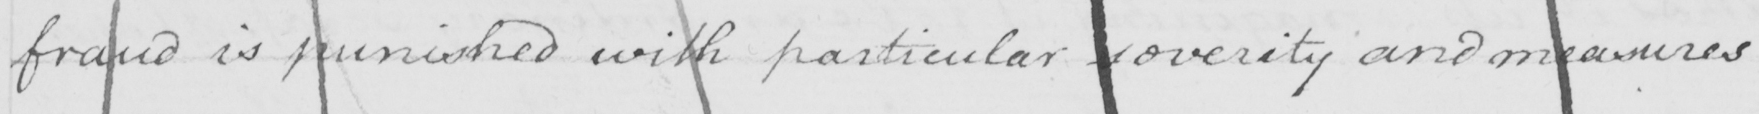What text is written in this handwritten line? fraud is punished with particular severity and measures 